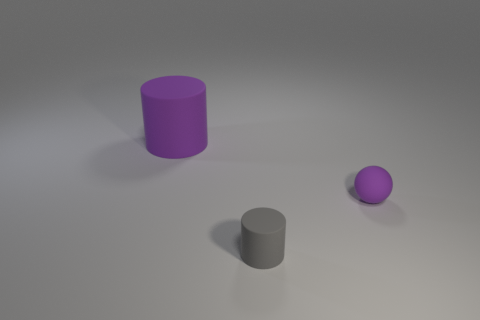The cylinder that is the same color as the small sphere is what size?
Provide a short and direct response. Large. What number of tiny spheres have the same color as the big rubber cylinder?
Your answer should be compact. 1. There is a big matte object that is the same color as the rubber ball; what is its shape?
Offer a very short reply. Cylinder. There is a cylinder in front of the large purple matte cylinder behind the tiny gray rubber thing; what is it made of?
Make the answer very short. Rubber. Is the number of tiny purple rubber balls in front of the purple cylinder greater than the number of small cyan shiny blocks?
Keep it short and to the point. Yes. Are there any other tiny gray cylinders that have the same material as the gray cylinder?
Offer a very short reply. No. Is the shape of the object that is on the left side of the tiny cylinder the same as  the tiny gray matte thing?
Ensure brevity in your answer.  Yes. What number of purple rubber objects are behind the tiny matte thing behind the cylinder that is in front of the small rubber ball?
Your response must be concise. 1. Are there fewer gray cylinders right of the large matte object than objects that are behind the tiny gray rubber cylinder?
Keep it short and to the point. Yes. What is the color of the other big matte object that is the same shape as the gray thing?
Ensure brevity in your answer.  Purple. 